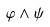<formula> <loc_0><loc_0><loc_500><loc_500>\varphi \wedge \psi</formula> 